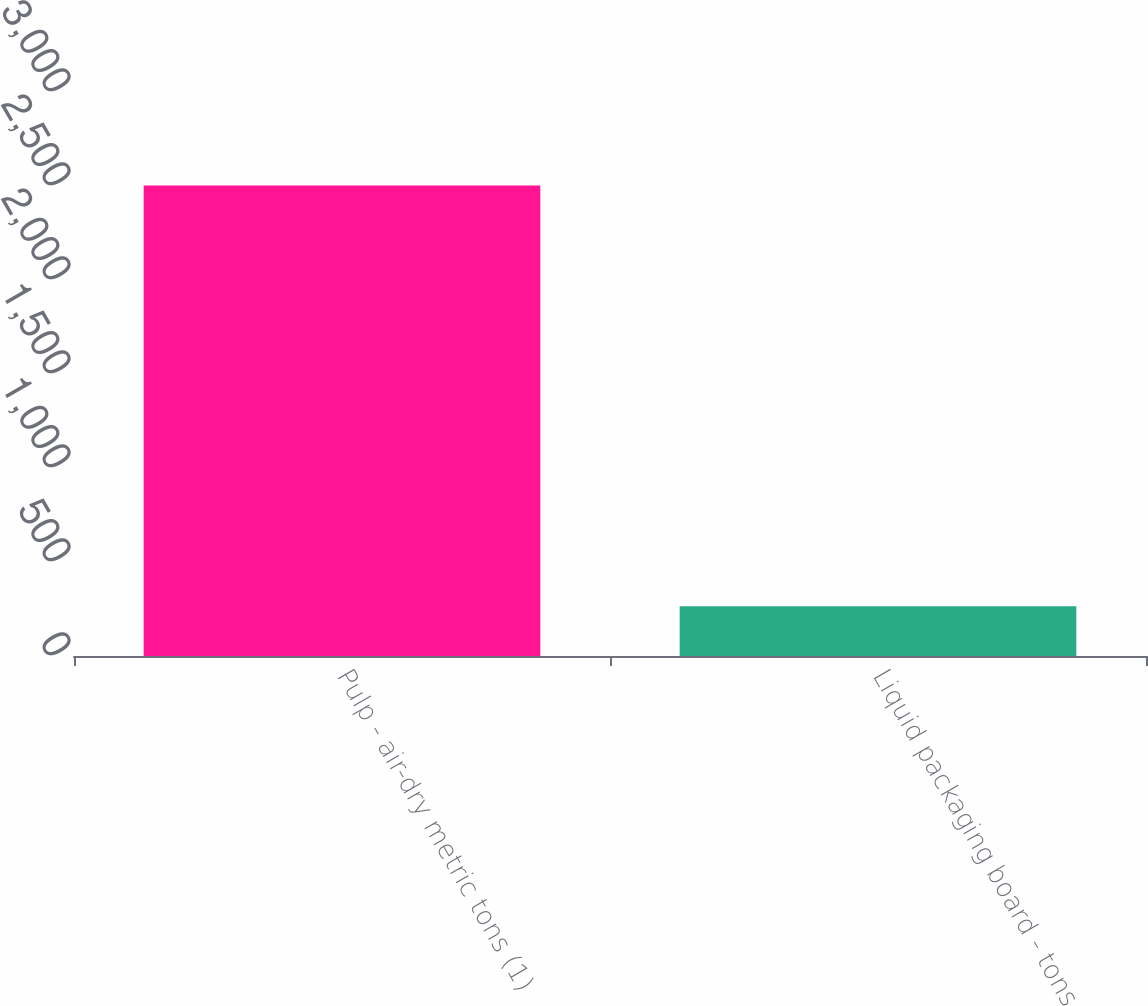Convert chart to OTSL. <chart><loc_0><loc_0><loc_500><loc_500><bar_chart><fcel>Pulp - air-dry metric tons (1)<fcel>Liquid packaging board - tons<nl><fcel>2502<fcel>264<nl></chart> 